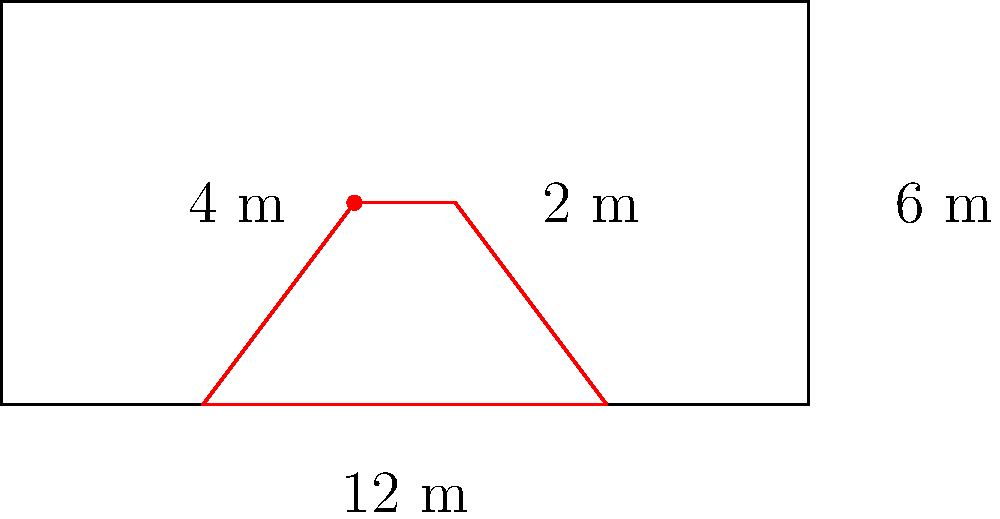A fire truck needs to pass through a narrow alleyway during an emergency response. The alleyway is 12 meters long and 6 meters wide. The fire truck is 4 meters long and 2 meters wide. What is the minimum angle of rotation needed for the fire truck to fit through the alleyway diagonally? To solve this problem, we'll use the principles of transformational geometry and trigonometry:

1. The diagonal of the alleyway forms the hypotenuse of a right triangle. We can calculate this using the Pythagorean theorem:
   $$d = \sqrt{12^2 + 6^2} = \sqrt{144 + 36} = \sqrt{180} = 6\sqrt{5}$$ meters

2. The diagonal of the fire truck also forms the hypotenuse of a right triangle:
   $$d_{truck} = \sqrt{4^2 + 2^2} = \sqrt{16 + 4} = \sqrt{20} = 2\sqrt{5}$$ meters

3. For the truck to fit diagonally, its diagonal must be less than or equal to the alleyway's width. We've confirmed this: $2\sqrt{5} < 6$

4. The minimum angle of rotation is the difference between the angle of the truck's diagonal and the angle of the alleyway's diagonal.

5. The angle of the alleyway's diagonal with respect to its length:
   $$\theta_{alley} = \arctan(\frac{6}{12}) = \arctan(0.5) \approx 26.57°$$

6. The angle of the truck's diagonal with respect to its length:
   $$\theta_{truck} = \arctan(\frac{2}{4}) = \arctan(0.5) \approx 26.57°$$

7. The minimum rotation angle is:
   $$\theta_{rotation} = \theta_{alley} - \theta_{truck} = 26.57° - 26.57° = 0°$$

Therefore, the fire truck can fit through the alleyway without any rotation.
Answer: 0° 